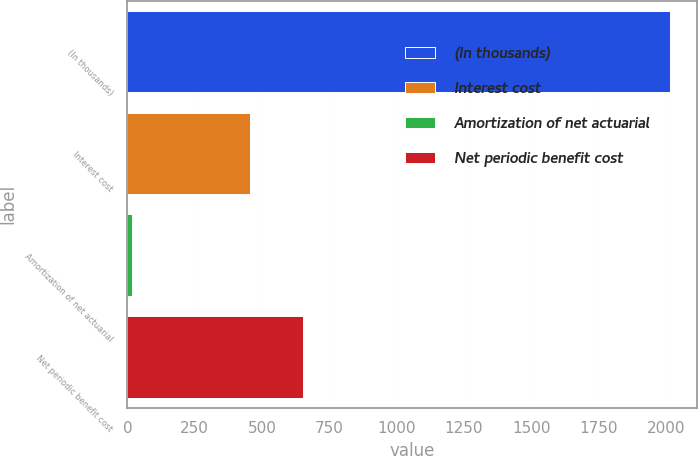Convert chart. <chart><loc_0><loc_0><loc_500><loc_500><bar_chart><fcel>(In thousands)<fcel>Interest cost<fcel>Amortization of net actuarial<fcel>Net periodic benefit cost<nl><fcel>2014<fcel>454<fcel>19<fcel>653.5<nl></chart> 